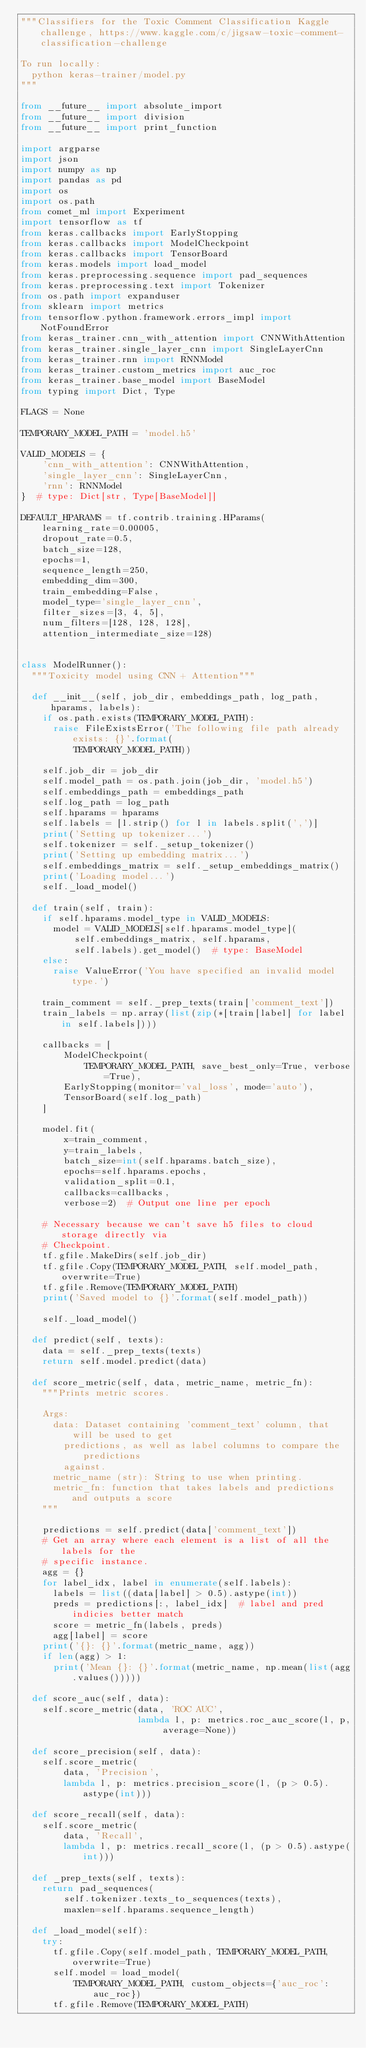<code> <loc_0><loc_0><loc_500><loc_500><_Python_>"""Classifiers for the Toxic Comment Classification Kaggle challenge, https://www.kaggle.com/c/jigsaw-toxic-comment-classification-challenge

To run locally:
  python keras-trainer/model.py
"""

from __future__ import absolute_import
from __future__ import division
from __future__ import print_function

import argparse
import json
import numpy as np
import pandas as pd
import os
import os.path
from comet_ml import Experiment
import tensorflow as tf
from keras.callbacks import EarlyStopping
from keras.callbacks import ModelCheckpoint
from keras.callbacks import TensorBoard
from keras.models import load_model
from keras.preprocessing.sequence import pad_sequences
from keras.preprocessing.text import Tokenizer
from os.path import expanduser
from sklearn import metrics
from tensorflow.python.framework.errors_impl import NotFoundError
from keras_trainer.cnn_with_attention import CNNWithAttention
from keras_trainer.single_layer_cnn import SingleLayerCnn
from keras_trainer.rnn import RNNModel
from keras_trainer.custom_metrics import auc_roc
from keras_trainer.base_model import BaseModel
from typing import Dict, Type

FLAGS = None

TEMPORARY_MODEL_PATH = 'model.h5'

VALID_MODELS = {
    'cnn_with_attention': CNNWithAttention,
    'single_layer_cnn': SingleLayerCnn,
    'rnn': RNNModel
}  # type: Dict[str, Type[BaseModel]]

DEFAULT_HPARAMS = tf.contrib.training.HParams(
    learning_rate=0.00005,
    dropout_rate=0.5,
    batch_size=128,
    epochs=1,
    sequence_length=250,
    embedding_dim=300,
    train_embedding=False,
    model_type='single_layer_cnn',
    filter_sizes=[3, 4, 5],
    num_filters=[128, 128, 128],
    attention_intermediate_size=128)


class ModelRunner():
  """Toxicity model using CNN + Attention"""

  def __init__(self, job_dir, embeddings_path, log_path, hparams, labels):
    if os.path.exists(TEMPORARY_MODEL_PATH):
      raise FileExistsError('The following file path already exists: {}'.format(
          TEMPORARY_MODEL_PATH))

    self.job_dir = job_dir
    self.model_path = os.path.join(job_dir, 'model.h5')
    self.embeddings_path = embeddings_path
    self.log_path = log_path
    self.hparams = hparams
    self.labels = [l.strip() for l in labels.split(',')]
    print('Setting up tokenizer...')
    self.tokenizer = self._setup_tokenizer()
    print('Setting up embedding matrix...')
    self.embeddings_matrix = self._setup_embeddings_matrix()
    print('Loading model...')
    self._load_model()

  def train(self, train):
    if self.hparams.model_type in VALID_MODELS:
      model = VALID_MODELS[self.hparams.model_type](
          self.embeddings_matrix, self.hparams,
          self.labels).get_model()  # type: BaseModel
    else:
      raise ValueError('You have specified an invalid model type.')

    train_comment = self._prep_texts(train['comment_text'])
    train_labels = np.array(list(zip(*[train[label] for label in self.labels])))

    callbacks = [
        ModelCheckpoint(
            TEMPORARY_MODEL_PATH, save_best_only=True, verbose=True),
        EarlyStopping(monitor='val_loss', mode='auto'),
        TensorBoard(self.log_path)
    ]

    model.fit(
        x=train_comment,
        y=train_labels,
        batch_size=int(self.hparams.batch_size),
        epochs=self.hparams.epochs,
        validation_split=0.1,
        callbacks=callbacks,
        verbose=2)  # Output one line per epoch

    # Necessary because we can't save h5 files to cloud storage directly via
    # Checkpoint.
    tf.gfile.MakeDirs(self.job_dir)
    tf.gfile.Copy(TEMPORARY_MODEL_PATH, self.model_path, overwrite=True)
    tf.gfile.Remove(TEMPORARY_MODEL_PATH)
    print('Saved model to {}'.format(self.model_path))

    self._load_model()

  def predict(self, texts):
    data = self._prep_texts(texts)
    return self.model.predict(data)

  def score_metric(self, data, metric_name, metric_fn):
    """Prints metric scores.

    Args:
      data: Dataset containing 'comment_text' column, that will be used to get
        predictions, as well as label columns to compare the predictions
        against.
      metric_name (str): String to use when printing.
      metric_fn: function that takes labels and predictions and outputs a score
    """

    predictions = self.predict(data['comment_text'])
    # Get an array where each element is a list of all the labels for the
    # specific instance.
    agg = {}
    for label_idx, label in enumerate(self.labels):
      labels = list((data[label] > 0.5).astype(int))
      preds = predictions[:, label_idx]  # label and pred indicies better match
      score = metric_fn(labels, preds)
      agg[label] = score
    print('{}: {}'.format(metric_name, agg))
    if len(agg) > 1:
      print('Mean {}: {}'.format(metric_name, np.mean(list(agg.values()))))

  def score_auc(self, data):
    self.score_metric(data, 'ROC AUC',
                      lambda l, p: metrics.roc_auc_score(l, p, average=None))

  def score_precision(self, data):
    self.score_metric(
        data, 'Precision',
        lambda l, p: metrics.precision_score(l, (p > 0.5).astype(int)))

  def score_recall(self, data):
    self.score_metric(
        data, 'Recall',
        lambda l, p: metrics.recall_score(l, (p > 0.5).astype(int)))

  def _prep_texts(self, texts):
    return pad_sequences(
        self.tokenizer.texts_to_sequences(texts),
        maxlen=self.hparams.sequence_length)

  def _load_model(self):
    try:
      tf.gfile.Copy(self.model_path, TEMPORARY_MODEL_PATH, overwrite=True)
      self.model = load_model(
          TEMPORARY_MODEL_PATH, custom_objects={'auc_roc': auc_roc})
      tf.gfile.Remove(TEMPORARY_MODEL_PATH)</code> 